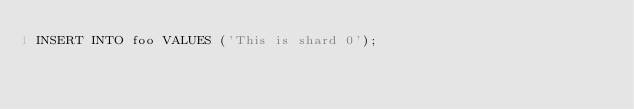<code> <loc_0><loc_0><loc_500><loc_500><_SQL_>INSERT INTO foo VALUES ('This is shard 0');
</code> 